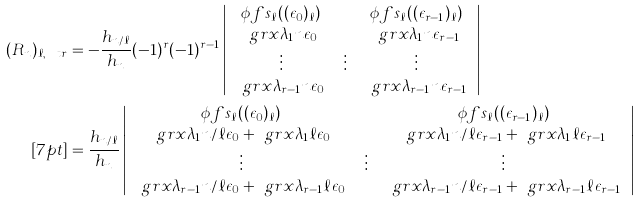Convert formula to latex. <formula><loc_0><loc_0><loc_500><loc_500>( R _ { n } ) _ { \ell , \ t r } & = - \frac { h _ { n / \ell } } { h _ { n } } ( - 1 ) ^ { r } ( - 1 ) ^ { r - 1 } \left | \begin{array} { c c c c c c c } \phi f s _ { \ell } ( ( \epsilon _ { 0 } ) _ { \ell } ) & \cdots & \phi f s _ { \ell } ( ( \epsilon _ { r - 1 } ) _ { \ell } ) \\ \ g r x { \lambda _ { 1 } } { n } { \epsilon _ { 0 } } & \cdots & \ g r x { \lambda _ { 1 } } { n } { \epsilon _ { r - 1 } } \\ \vdots & \vdots & \vdots \\ \ g r x { \lambda _ { r - 1 } } { n } { \epsilon _ { 0 } } & \cdots & \ g r x { \lambda _ { r - 1 } } { n } { \epsilon _ { r - 1 } } \end{array} \right | \\ [ 7 p t ] & = \frac { h _ { n / \ell } } { h _ { n } } \left | \begin{array} { c c c c c c c } \phi f s _ { \ell } ( ( \epsilon _ { 0 } ) _ { \ell } ) & \cdots & \phi f s _ { \ell } ( ( \epsilon _ { r - 1 } ) _ { \ell } ) \\ \ g r x { \lambda _ { 1 } } { n / \ell } { \epsilon _ { 0 } } + \ g r x { \lambda _ { 1 } } { \ell } { \epsilon _ { 0 } } & \cdots & \ g r x { \lambda _ { 1 } } { n / \ell } { \epsilon _ { r - 1 } } + \ g r x { \lambda _ { 1 } } { \ell } { \epsilon _ { r - 1 } } \\ \vdots & \vdots & \vdots \\ \ g r x { \lambda _ { r - 1 } } { n / \ell } { \epsilon _ { 0 } } + \ g r x { \lambda _ { r - 1 } } { \ell } { \epsilon _ { 0 } } & \cdots & \ g r x { \lambda _ { r - 1 } } { n / \ell } { \epsilon _ { r - 1 } } + \ g r x { \lambda _ { r - 1 } } { \ell } { \epsilon _ { r - 1 } } \end{array} \right |</formula> 